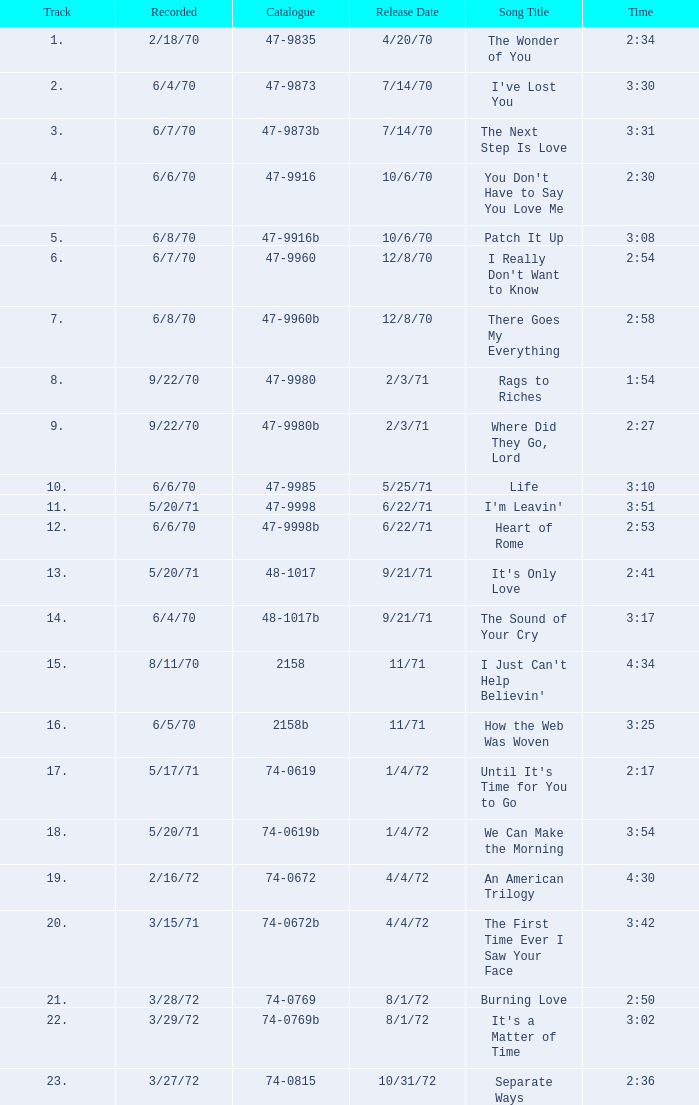Which song was released 12/8/70 with a time of 2:54? I Really Don't Want to Know. Would you mind parsing the complete table? {'header': ['Track', 'Recorded', 'Catalogue', 'Release Date', 'Song Title', 'Time'], 'rows': [['1.', '2/18/70', '47-9835', '4/20/70', 'The Wonder of You', '2:34'], ['2.', '6/4/70', '47-9873', '7/14/70', "I've Lost You", '3:30'], ['3.', '6/7/70', '47-9873b', '7/14/70', 'The Next Step Is Love', '3:31'], ['4.', '6/6/70', '47-9916', '10/6/70', "You Don't Have to Say You Love Me", '2:30'], ['5.', '6/8/70', '47-9916b', '10/6/70', 'Patch It Up', '3:08'], ['6.', '6/7/70', '47-9960', '12/8/70', "I Really Don't Want to Know", '2:54'], ['7.', '6/8/70', '47-9960b', '12/8/70', 'There Goes My Everything', '2:58'], ['8.', '9/22/70', '47-9980', '2/3/71', 'Rags to Riches', '1:54'], ['9.', '9/22/70', '47-9980b', '2/3/71', 'Where Did They Go, Lord', '2:27'], ['10.', '6/6/70', '47-9985', '5/25/71', 'Life', '3:10'], ['11.', '5/20/71', '47-9998', '6/22/71', "I'm Leavin'", '3:51'], ['12.', '6/6/70', '47-9998b', '6/22/71', 'Heart of Rome', '2:53'], ['13.', '5/20/71', '48-1017', '9/21/71', "It's Only Love", '2:41'], ['14.', '6/4/70', '48-1017b', '9/21/71', 'The Sound of Your Cry', '3:17'], ['15.', '8/11/70', '2158', '11/71', "I Just Can't Help Believin'", '4:34'], ['16.', '6/5/70', '2158b', '11/71', 'How the Web Was Woven', '3:25'], ['17.', '5/17/71', '74-0619', '1/4/72', "Until It's Time for You to Go", '2:17'], ['18.', '5/20/71', '74-0619b', '1/4/72', 'We Can Make the Morning', '3:54'], ['19.', '2/16/72', '74-0672', '4/4/72', 'An American Trilogy', '4:30'], ['20.', '3/15/71', '74-0672b', '4/4/72', 'The First Time Ever I Saw Your Face', '3:42'], ['21.', '3/28/72', '74-0769', '8/1/72', 'Burning Love', '2:50'], ['22.', '3/29/72', '74-0769b', '8/1/72', "It's a Matter of Time", '3:02'], ['23.', '3/27/72', '74-0815', '10/31/72', 'Separate Ways', '2:36']]} 